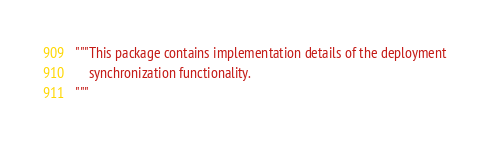<code> <loc_0><loc_0><loc_500><loc_500><_Python_>"""This package contains implementation details of the deployment
    synchronization functionality.
"""
</code> 